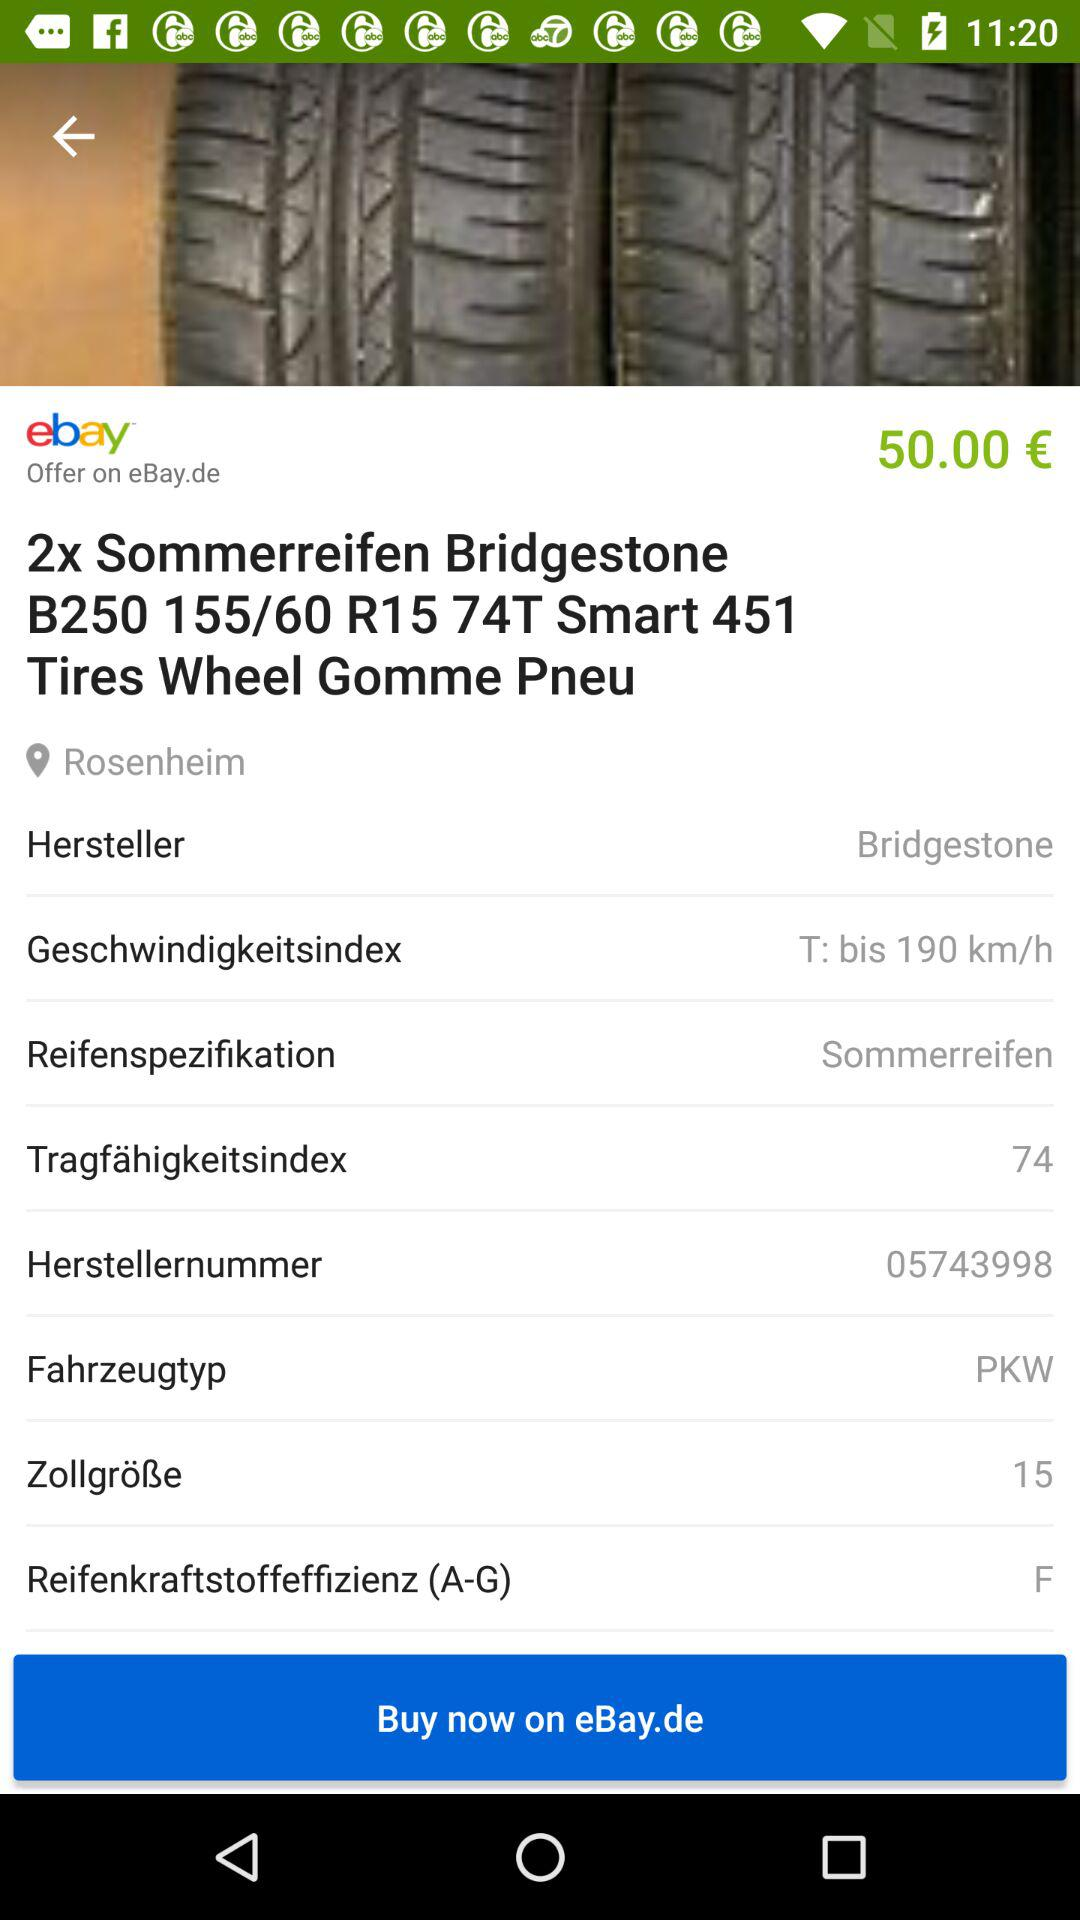What is the price of the tires?
Answer the question using a single word or phrase. 50.00 € 